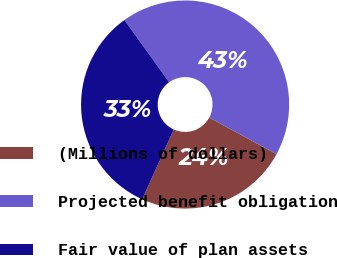Convert chart. <chart><loc_0><loc_0><loc_500><loc_500><pie_chart><fcel>(Millions of dollars)<fcel>Projected benefit obligation<fcel>Fair value of plan assets<nl><fcel>23.86%<fcel>42.81%<fcel>33.33%<nl></chart> 